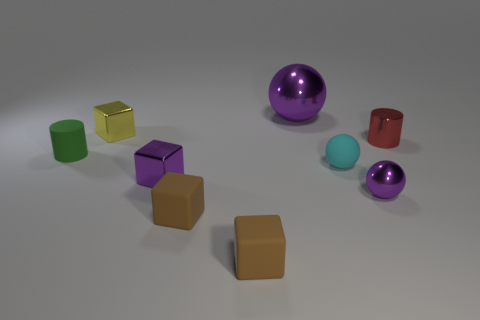There is a purple metal thing on the right side of the cyan matte thing; is it the same shape as the large purple shiny object?
Make the answer very short. Yes. Is there another big matte thing of the same shape as the big purple thing?
Give a very brief answer. No. What material is the cube that is the same color as the small metallic sphere?
Your answer should be compact. Metal. The small purple object left of the purple object behind the cyan sphere is what shape?
Provide a short and direct response. Cube. What number of tiny yellow cylinders have the same material as the red cylinder?
Ensure brevity in your answer.  0. The small ball that is made of the same material as the big purple thing is what color?
Your answer should be compact. Purple. How big is the purple metal sphere that is behind the tiny purple thing in front of the metallic cube in front of the green object?
Your response must be concise. Large. Is the number of tiny green rubber cylinders less than the number of spheres?
Make the answer very short. Yes. There is a tiny rubber thing that is the same shape as the small red shiny object; what is its color?
Your answer should be compact. Green. Is there a small object behind the purple metallic ball in front of the tiny metal cylinder that is behind the cyan thing?
Provide a succinct answer. Yes. 